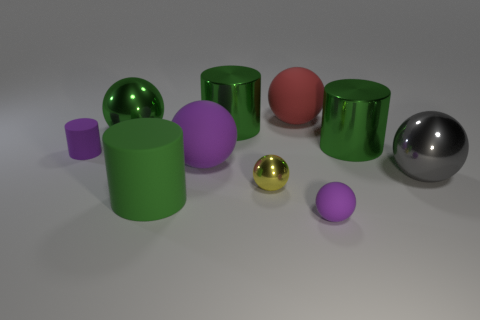Subtract all yellow spheres. How many green cylinders are left? 3 Subtract 2 balls. How many balls are left? 4 Subtract all small purple rubber balls. How many balls are left? 5 Subtract all yellow balls. How many balls are left? 5 Subtract all blue cylinders. Subtract all gray blocks. How many cylinders are left? 4 Subtract all balls. How many objects are left? 4 Add 4 large cubes. How many large cubes exist? 4 Subtract 0 green blocks. How many objects are left? 10 Subtract all matte balls. Subtract all large shiny cylinders. How many objects are left? 5 Add 2 large rubber objects. How many large rubber objects are left? 5 